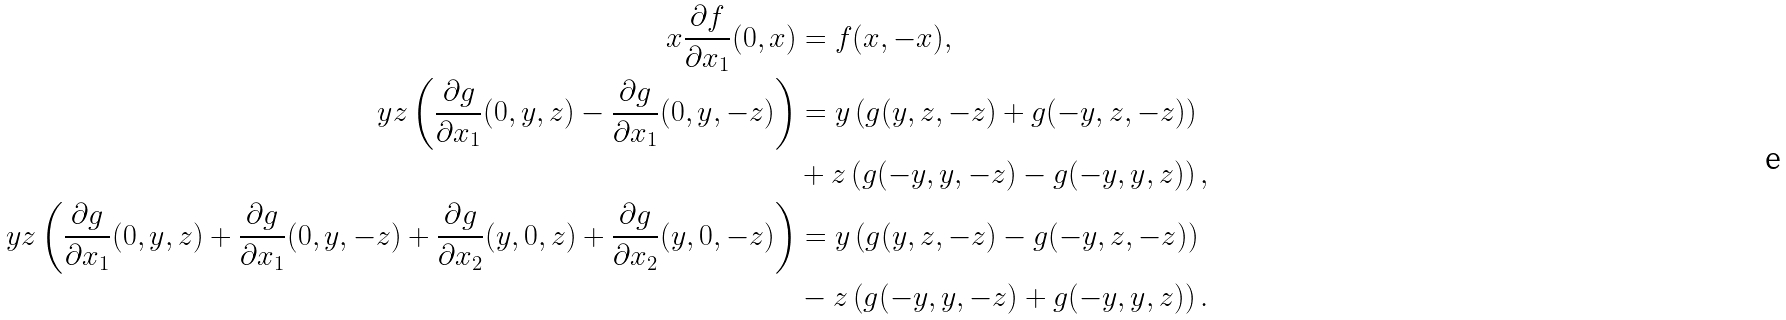<formula> <loc_0><loc_0><loc_500><loc_500>x \frac { \partial f } { \partial x _ { 1 } } ( 0 , x ) & = f ( x , - x ) , \\ y z \left ( \frac { \partial g } { \partial x _ { 1 } } ( 0 , y , z ) - \frac { \partial g } { \partial x _ { 1 } } ( 0 , y , - z ) \right ) & = y \left ( g ( y , z , - z ) + g ( - y , z , - z ) \right ) \\ & + z \left ( g ( - y , y , - z ) - g ( - y , y , z ) \right ) , \\ y z \left ( \frac { \partial g } { \partial x _ { 1 } } ( 0 , y , z ) + \frac { \partial g } { \partial x _ { 1 } } ( 0 , y , - z ) + \frac { \partial g } { \partial x _ { 2 } } ( y , 0 , z ) + \frac { \partial g } { \partial x _ { 2 } } ( y , 0 , - z ) \right ) & = y \left ( g ( y , z , - z ) - g ( - y , z , - z ) \right ) \\ & - z \left ( g ( - y , y , - z ) + g ( - y , y , z ) \right ) .</formula> 